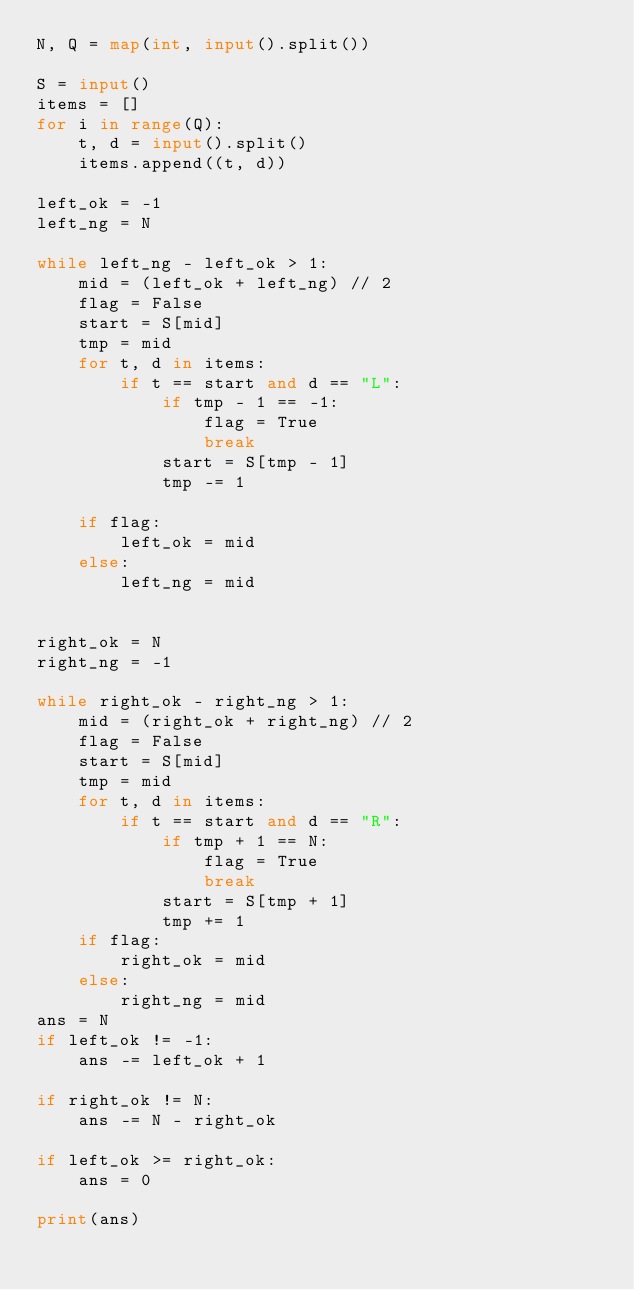<code> <loc_0><loc_0><loc_500><loc_500><_Python_>N, Q = map(int, input().split())

S = input()
items = []
for i in range(Q):
    t, d = input().split()
    items.append((t, d))

left_ok = -1
left_ng = N

while left_ng - left_ok > 1:
    mid = (left_ok + left_ng) // 2
    flag = False
    start = S[mid]
    tmp = mid
    for t, d in items:
        if t == start and d == "L":
            if tmp - 1 == -1:
                flag = True
                break
            start = S[tmp - 1]
            tmp -= 1

    if flag:
        left_ok = mid
    else:
        left_ng = mid


right_ok = N
right_ng = -1

while right_ok - right_ng > 1:
    mid = (right_ok + right_ng) // 2
    flag = False
    start = S[mid]
    tmp = mid
    for t, d in items:
        if t == start and d == "R":
            if tmp + 1 == N:
                flag = True
                break
            start = S[tmp + 1]
            tmp += 1
    if flag:
        right_ok = mid
    else:
        right_ng = mid
ans = N
if left_ok != -1:
    ans -= left_ok + 1

if right_ok != N:
    ans -= N - right_ok

if left_ok >= right_ok:
    ans = 0

print(ans)
</code> 